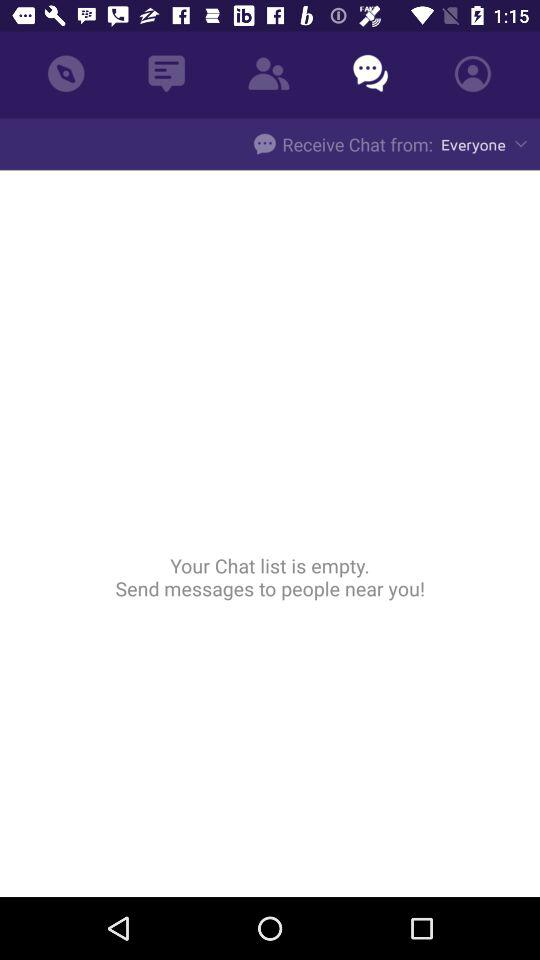What is the option selected for "Receive Chat from"? The selected option is "Everyone". 